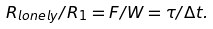Convert formula to latex. <formula><loc_0><loc_0><loc_500><loc_500>R _ { l o n e l y } / R _ { 1 } = F / W = \tau / \Delta t .</formula> 